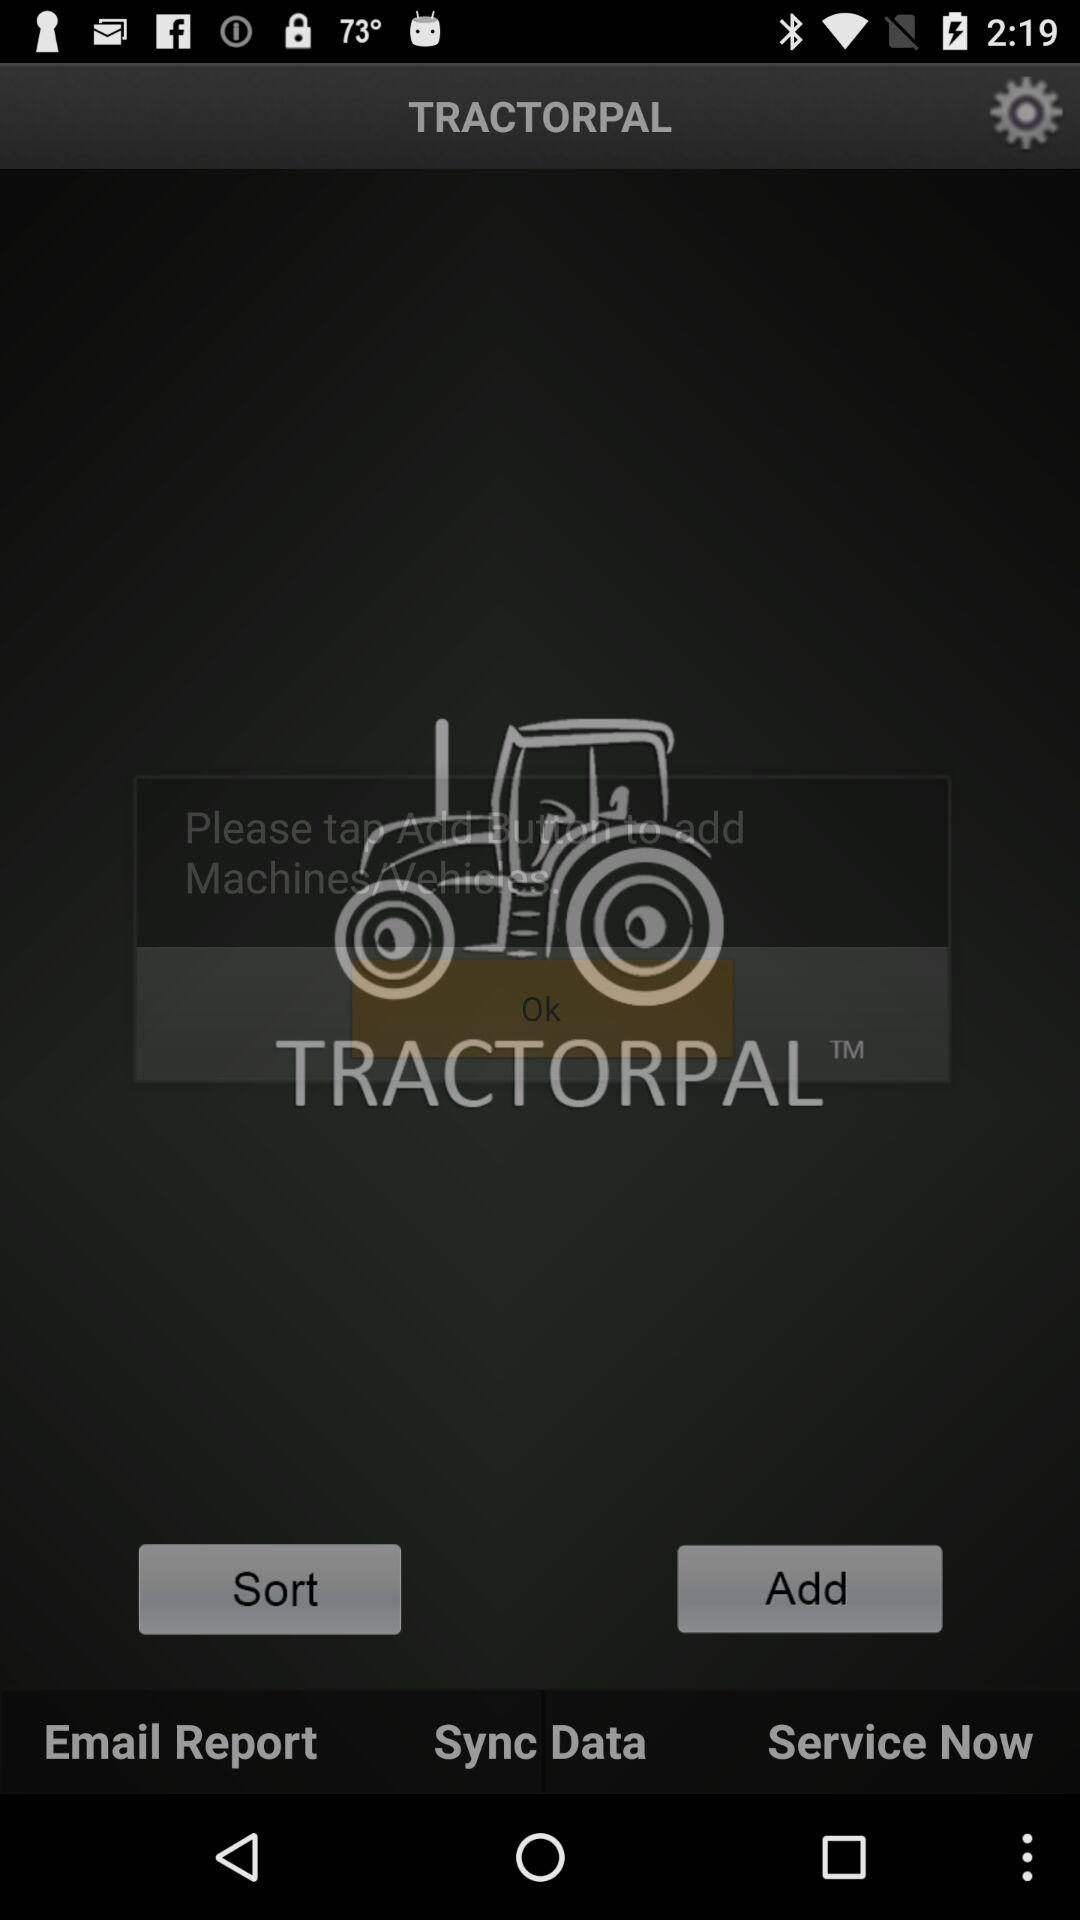What is the name of the application? The name of the application is "TRACTORPAL". 